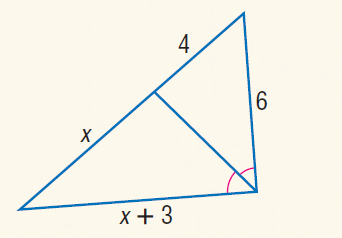Answer the mathemtical geometry problem and directly provide the correct option letter.
Question: Find x.
Choices: A: 6 B: 7 C: 8 D: 9 A 